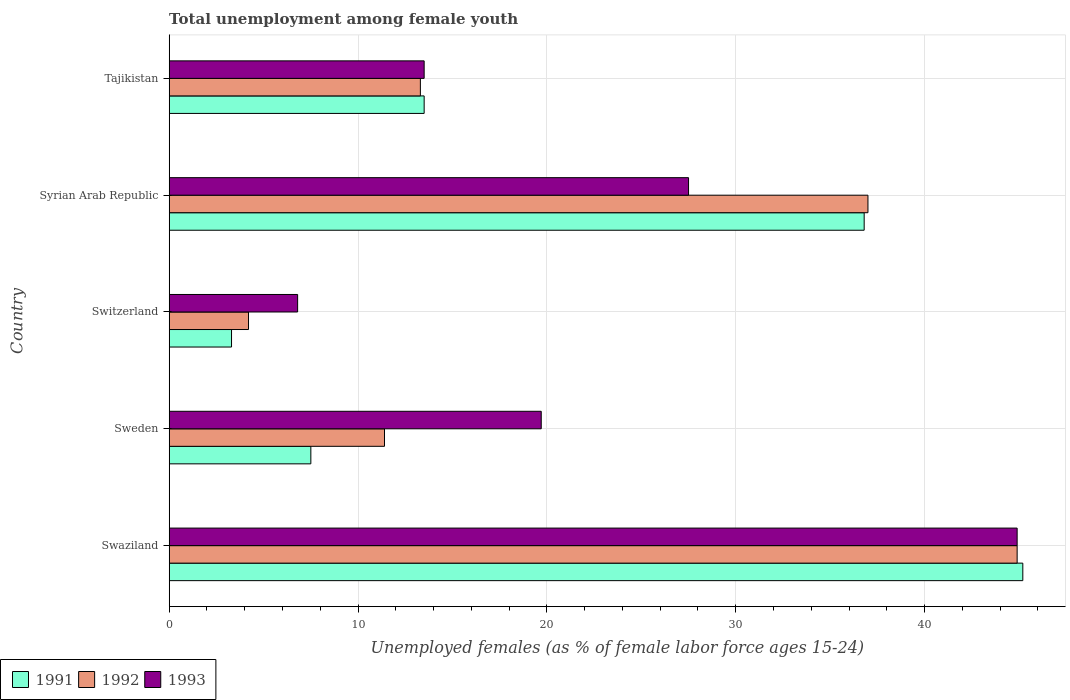Are the number of bars on each tick of the Y-axis equal?
Provide a short and direct response. Yes. How many bars are there on the 3rd tick from the bottom?
Provide a short and direct response. 3. What is the label of the 5th group of bars from the top?
Make the answer very short. Swaziland. Across all countries, what is the maximum percentage of unemployed females in in 1992?
Make the answer very short. 44.9. Across all countries, what is the minimum percentage of unemployed females in in 1991?
Offer a very short reply. 3.3. In which country was the percentage of unemployed females in in 1993 maximum?
Keep it short and to the point. Swaziland. In which country was the percentage of unemployed females in in 1991 minimum?
Offer a terse response. Switzerland. What is the total percentage of unemployed females in in 1992 in the graph?
Make the answer very short. 110.8. What is the difference between the percentage of unemployed females in in 1991 in Sweden and that in Syrian Arab Republic?
Ensure brevity in your answer.  -29.3. What is the difference between the percentage of unemployed females in in 1993 in Swaziland and the percentage of unemployed females in in 1991 in Sweden?
Provide a short and direct response. 37.4. What is the average percentage of unemployed females in in 1993 per country?
Ensure brevity in your answer.  22.48. What is the difference between the percentage of unemployed females in in 1992 and percentage of unemployed females in in 1991 in Switzerland?
Give a very brief answer. 0.9. In how many countries, is the percentage of unemployed females in in 1993 greater than 14 %?
Give a very brief answer. 3. What is the ratio of the percentage of unemployed females in in 1991 in Switzerland to that in Syrian Arab Republic?
Your answer should be compact. 0.09. Is the difference between the percentage of unemployed females in in 1992 in Swaziland and Switzerland greater than the difference between the percentage of unemployed females in in 1991 in Swaziland and Switzerland?
Provide a succinct answer. No. What is the difference between the highest and the second highest percentage of unemployed females in in 1992?
Your answer should be compact. 7.9. What is the difference between the highest and the lowest percentage of unemployed females in in 1991?
Your answer should be very brief. 41.9. In how many countries, is the percentage of unemployed females in in 1992 greater than the average percentage of unemployed females in in 1992 taken over all countries?
Keep it short and to the point. 2. What does the 3rd bar from the bottom in Swaziland represents?
Keep it short and to the point. 1993. Is it the case that in every country, the sum of the percentage of unemployed females in in 1993 and percentage of unemployed females in in 1992 is greater than the percentage of unemployed females in in 1991?
Keep it short and to the point. Yes. How many bars are there?
Provide a short and direct response. 15. What is the difference between two consecutive major ticks on the X-axis?
Your answer should be very brief. 10. Are the values on the major ticks of X-axis written in scientific E-notation?
Offer a very short reply. No. Does the graph contain grids?
Offer a terse response. Yes. Where does the legend appear in the graph?
Offer a terse response. Bottom left. How many legend labels are there?
Provide a short and direct response. 3. How are the legend labels stacked?
Offer a terse response. Horizontal. What is the title of the graph?
Keep it short and to the point. Total unemployment among female youth. Does "1971" appear as one of the legend labels in the graph?
Your answer should be compact. No. What is the label or title of the X-axis?
Provide a succinct answer. Unemployed females (as % of female labor force ages 15-24). What is the label or title of the Y-axis?
Offer a very short reply. Country. What is the Unemployed females (as % of female labor force ages 15-24) in 1991 in Swaziland?
Offer a terse response. 45.2. What is the Unemployed females (as % of female labor force ages 15-24) of 1992 in Swaziland?
Make the answer very short. 44.9. What is the Unemployed females (as % of female labor force ages 15-24) in 1993 in Swaziland?
Ensure brevity in your answer.  44.9. What is the Unemployed females (as % of female labor force ages 15-24) in 1992 in Sweden?
Make the answer very short. 11.4. What is the Unemployed females (as % of female labor force ages 15-24) of 1993 in Sweden?
Give a very brief answer. 19.7. What is the Unemployed females (as % of female labor force ages 15-24) of 1991 in Switzerland?
Your answer should be very brief. 3.3. What is the Unemployed females (as % of female labor force ages 15-24) in 1992 in Switzerland?
Give a very brief answer. 4.2. What is the Unemployed females (as % of female labor force ages 15-24) of 1993 in Switzerland?
Keep it short and to the point. 6.8. What is the Unemployed females (as % of female labor force ages 15-24) of 1991 in Syrian Arab Republic?
Give a very brief answer. 36.8. What is the Unemployed females (as % of female labor force ages 15-24) of 1992 in Syrian Arab Republic?
Your answer should be compact. 37. What is the Unemployed females (as % of female labor force ages 15-24) in 1991 in Tajikistan?
Make the answer very short. 13.5. What is the Unemployed females (as % of female labor force ages 15-24) of 1992 in Tajikistan?
Keep it short and to the point. 13.3. Across all countries, what is the maximum Unemployed females (as % of female labor force ages 15-24) in 1991?
Provide a short and direct response. 45.2. Across all countries, what is the maximum Unemployed females (as % of female labor force ages 15-24) of 1992?
Keep it short and to the point. 44.9. Across all countries, what is the maximum Unemployed females (as % of female labor force ages 15-24) in 1993?
Keep it short and to the point. 44.9. Across all countries, what is the minimum Unemployed females (as % of female labor force ages 15-24) in 1991?
Your answer should be compact. 3.3. Across all countries, what is the minimum Unemployed females (as % of female labor force ages 15-24) of 1992?
Make the answer very short. 4.2. Across all countries, what is the minimum Unemployed females (as % of female labor force ages 15-24) in 1993?
Provide a short and direct response. 6.8. What is the total Unemployed females (as % of female labor force ages 15-24) in 1991 in the graph?
Offer a very short reply. 106.3. What is the total Unemployed females (as % of female labor force ages 15-24) in 1992 in the graph?
Provide a short and direct response. 110.8. What is the total Unemployed females (as % of female labor force ages 15-24) in 1993 in the graph?
Provide a succinct answer. 112.4. What is the difference between the Unemployed females (as % of female labor force ages 15-24) of 1991 in Swaziland and that in Sweden?
Offer a terse response. 37.7. What is the difference between the Unemployed females (as % of female labor force ages 15-24) of 1992 in Swaziland and that in Sweden?
Your answer should be very brief. 33.5. What is the difference between the Unemployed females (as % of female labor force ages 15-24) of 1993 in Swaziland and that in Sweden?
Your response must be concise. 25.2. What is the difference between the Unemployed females (as % of female labor force ages 15-24) of 1991 in Swaziland and that in Switzerland?
Offer a very short reply. 41.9. What is the difference between the Unemployed females (as % of female labor force ages 15-24) of 1992 in Swaziland and that in Switzerland?
Give a very brief answer. 40.7. What is the difference between the Unemployed females (as % of female labor force ages 15-24) of 1993 in Swaziland and that in Switzerland?
Give a very brief answer. 38.1. What is the difference between the Unemployed females (as % of female labor force ages 15-24) of 1992 in Swaziland and that in Syrian Arab Republic?
Make the answer very short. 7.9. What is the difference between the Unemployed females (as % of female labor force ages 15-24) of 1991 in Swaziland and that in Tajikistan?
Keep it short and to the point. 31.7. What is the difference between the Unemployed females (as % of female labor force ages 15-24) in 1992 in Swaziland and that in Tajikistan?
Give a very brief answer. 31.6. What is the difference between the Unemployed females (as % of female labor force ages 15-24) in 1993 in Swaziland and that in Tajikistan?
Offer a terse response. 31.4. What is the difference between the Unemployed females (as % of female labor force ages 15-24) of 1991 in Sweden and that in Switzerland?
Your answer should be compact. 4.2. What is the difference between the Unemployed females (as % of female labor force ages 15-24) of 1992 in Sweden and that in Switzerland?
Your answer should be very brief. 7.2. What is the difference between the Unemployed females (as % of female labor force ages 15-24) of 1991 in Sweden and that in Syrian Arab Republic?
Your response must be concise. -29.3. What is the difference between the Unemployed females (as % of female labor force ages 15-24) of 1992 in Sweden and that in Syrian Arab Republic?
Your answer should be very brief. -25.6. What is the difference between the Unemployed females (as % of female labor force ages 15-24) of 1993 in Sweden and that in Syrian Arab Republic?
Ensure brevity in your answer.  -7.8. What is the difference between the Unemployed females (as % of female labor force ages 15-24) of 1991 in Sweden and that in Tajikistan?
Your answer should be very brief. -6. What is the difference between the Unemployed females (as % of female labor force ages 15-24) in 1992 in Sweden and that in Tajikistan?
Your answer should be compact. -1.9. What is the difference between the Unemployed females (as % of female labor force ages 15-24) in 1991 in Switzerland and that in Syrian Arab Republic?
Offer a terse response. -33.5. What is the difference between the Unemployed females (as % of female labor force ages 15-24) in 1992 in Switzerland and that in Syrian Arab Republic?
Offer a terse response. -32.8. What is the difference between the Unemployed females (as % of female labor force ages 15-24) of 1993 in Switzerland and that in Syrian Arab Republic?
Make the answer very short. -20.7. What is the difference between the Unemployed females (as % of female labor force ages 15-24) of 1993 in Switzerland and that in Tajikistan?
Keep it short and to the point. -6.7. What is the difference between the Unemployed females (as % of female labor force ages 15-24) of 1991 in Syrian Arab Republic and that in Tajikistan?
Provide a succinct answer. 23.3. What is the difference between the Unemployed females (as % of female labor force ages 15-24) of 1992 in Syrian Arab Republic and that in Tajikistan?
Provide a short and direct response. 23.7. What is the difference between the Unemployed females (as % of female labor force ages 15-24) in 1993 in Syrian Arab Republic and that in Tajikistan?
Keep it short and to the point. 14. What is the difference between the Unemployed females (as % of female labor force ages 15-24) of 1991 in Swaziland and the Unemployed females (as % of female labor force ages 15-24) of 1992 in Sweden?
Your answer should be compact. 33.8. What is the difference between the Unemployed females (as % of female labor force ages 15-24) in 1991 in Swaziland and the Unemployed females (as % of female labor force ages 15-24) in 1993 in Sweden?
Keep it short and to the point. 25.5. What is the difference between the Unemployed females (as % of female labor force ages 15-24) of 1992 in Swaziland and the Unemployed females (as % of female labor force ages 15-24) of 1993 in Sweden?
Offer a terse response. 25.2. What is the difference between the Unemployed females (as % of female labor force ages 15-24) in 1991 in Swaziland and the Unemployed females (as % of female labor force ages 15-24) in 1992 in Switzerland?
Ensure brevity in your answer.  41. What is the difference between the Unemployed females (as % of female labor force ages 15-24) in 1991 in Swaziland and the Unemployed females (as % of female labor force ages 15-24) in 1993 in Switzerland?
Your answer should be compact. 38.4. What is the difference between the Unemployed females (as % of female labor force ages 15-24) in 1992 in Swaziland and the Unemployed females (as % of female labor force ages 15-24) in 1993 in Switzerland?
Make the answer very short. 38.1. What is the difference between the Unemployed females (as % of female labor force ages 15-24) in 1992 in Swaziland and the Unemployed females (as % of female labor force ages 15-24) in 1993 in Syrian Arab Republic?
Make the answer very short. 17.4. What is the difference between the Unemployed females (as % of female labor force ages 15-24) of 1991 in Swaziland and the Unemployed females (as % of female labor force ages 15-24) of 1992 in Tajikistan?
Give a very brief answer. 31.9. What is the difference between the Unemployed females (as % of female labor force ages 15-24) in 1991 in Swaziland and the Unemployed females (as % of female labor force ages 15-24) in 1993 in Tajikistan?
Ensure brevity in your answer.  31.7. What is the difference between the Unemployed females (as % of female labor force ages 15-24) of 1992 in Swaziland and the Unemployed females (as % of female labor force ages 15-24) of 1993 in Tajikistan?
Provide a succinct answer. 31.4. What is the difference between the Unemployed females (as % of female labor force ages 15-24) of 1991 in Sweden and the Unemployed females (as % of female labor force ages 15-24) of 1993 in Switzerland?
Provide a short and direct response. 0.7. What is the difference between the Unemployed females (as % of female labor force ages 15-24) of 1992 in Sweden and the Unemployed females (as % of female labor force ages 15-24) of 1993 in Switzerland?
Your answer should be very brief. 4.6. What is the difference between the Unemployed females (as % of female labor force ages 15-24) of 1991 in Sweden and the Unemployed females (as % of female labor force ages 15-24) of 1992 in Syrian Arab Republic?
Your answer should be very brief. -29.5. What is the difference between the Unemployed females (as % of female labor force ages 15-24) in 1991 in Sweden and the Unemployed females (as % of female labor force ages 15-24) in 1993 in Syrian Arab Republic?
Offer a very short reply. -20. What is the difference between the Unemployed females (as % of female labor force ages 15-24) of 1992 in Sweden and the Unemployed females (as % of female labor force ages 15-24) of 1993 in Syrian Arab Republic?
Your answer should be compact. -16.1. What is the difference between the Unemployed females (as % of female labor force ages 15-24) of 1991 in Switzerland and the Unemployed females (as % of female labor force ages 15-24) of 1992 in Syrian Arab Republic?
Offer a terse response. -33.7. What is the difference between the Unemployed females (as % of female labor force ages 15-24) in 1991 in Switzerland and the Unemployed females (as % of female labor force ages 15-24) in 1993 in Syrian Arab Republic?
Ensure brevity in your answer.  -24.2. What is the difference between the Unemployed females (as % of female labor force ages 15-24) of 1992 in Switzerland and the Unemployed females (as % of female labor force ages 15-24) of 1993 in Syrian Arab Republic?
Keep it short and to the point. -23.3. What is the difference between the Unemployed females (as % of female labor force ages 15-24) in 1991 in Switzerland and the Unemployed females (as % of female labor force ages 15-24) in 1992 in Tajikistan?
Your answer should be very brief. -10. What is the difference between the Unemployed females (as % of female labor force ages 15-24) of 1991 in Syrian Arab Republic and the Unemployed females (as % of female labor force ages 15-24) of 1993 in Tajikistan?
Keep it short and to the point. 23.3. What is the average Unemployed females (as % of female labor force ages 15-24) of 1991 per country?
Offer a terse response. 21.26. What is the average Unemployed females (as % of female labor force ages 15-24) in 1992 per country?
Give a very brief answer. 22.16. What is the average Unemployed females (as % of female labor force ages 15-24) in 1993 per country?
Ensure brevity in your answer.  22.48. What is the difference between the Unemployed females (as % of female labor force ages 15-24) of 1992 and Unemployed females (as % of female labor force ages 15-24) of 1993 in Sweden?
Offer a very short reply. -8.3. What is the difference between the Unemployed females (as % of female labor force ages 15-24) of 1991 and Unemployed females (as % of female labor force ages 15-24) of 1993 in Switzerland?
Offer a terse response. -3.5. What is the difference between the Unemployed females (as % of female labor force ages 15-24) of 1992 and Unemployed females (as % of female labor force ages 15-24) of 1993 in Switzerland?
Keep it short and to the point. -2.6. What is the difference between the Unemployed females (as % of female labor force ages 15-24) in 1992 and Unemployed females (as % of female labor force ages 15-24) in 1993 in Syrian Arab Republic?
Ensure brevity in your answer.  9.5. What is the difference between the Unemployed females (as % of female labor force ages 15-24) in 1991 and Unemployed females (as % of female labor force ages 15-24) in 1992 in Tajikistan?
Ensure brevity in your answer.  0.2. What is the difference between the Unemployed females (as % of female labor force ages 15-24) of 1992 and Unemployed females (as % of female labor force ages 15-24) of 1993 in Tajikistan?
Provide a short and direct response. -0.2. What is the ratio of the Unemployed females (as % of female labor force ages 15-24) in 1991 in Swaziland to that in Sweden?
Keep it short and to the point. 6.03. What is the ratio of the Unemployed females (as % of female labor force ages 15-24) in 1992 in Swaziland to that in Sweden?
Offer a terse response. 3.94. What is the ratio of the Unemployed females (as % of female labor force ages 15-24) in 1993 in Swaziland to that in Sweden?
Give a very brief answer. 2.28. What is the ratio of the Unemployed females (as % of female labor force ages 15-24) of 1991 in Swaziland to that in Switzerland?
Offer a terse response. 13.7. What is the ratio of the Unemployed females (as % of female labor force ages 15-24) of 1992 in Swaziland to that in Switzerland?
Offer a terse response. 10.69. What is the ratio of the Unemployed females (as % of female labor force ages 15-24) of 1993 in Swaziland to that in Switzerland?
Your answer should be compact. 6.6. What is the ratio of the Unemployed females (as % of female labor force ages 15-24) in 1991 in Swaziland to that in Syrian Arab Republic?
Provide a succinct answer. 1.23. What is the ratio of the Unemployed females (as % of female labor force ages 15-24) in 1992 in Swaziland to that in Syrian Arab Republic?
Keep it short and to the point. 1.21. What is the ratio of the Unemployed females (as % of female labor force ages 15-24) of 1993 in Swaziland to that in Syrian Arab Republic?
Your answer should be very brief. 1.63. What is the ratio of the Unemployed females (as % of female labor force ages 15-24) in 1991 in Swaziland to that in Tajikistan?
Make the answer very short. 3.35. What is the ratio of the Unemployed females (as % of female labor force ages 15-24) in 1992 in Swaziland to that in Tajikistan?
Offer a terse response. 3.38. What is the ratio of the Unemployed females (as % of female labor force ages 15-24) in 1993 in Swaziland to that in Tajikistan?
Your answer should be compact. 3.33. What is the ratio of the Unemployed females (as % of female labor force ages 15-24) in 1991 in Sweden to that in Switzerland?
Keep it short and to the point. 2.27. What is the ratio of the Unemployed females (as % of female labor force ages 15-24) of 1992 in Sweden to that in Switzerland?
Give a very brief answer. 2.71. What is the ratio of the Unemployed females (as % of female labor force ages 15-24) in 1993 in Sweden to that in Switzerland?
Ensure brevity in your answer.  2.9. What is the ratio of the Unemployed females (as % of female labor force ages 15-24) in 1991 in Sweden to that in Syrian Arab Republic?
Provide a succinct answer. 0.2. What is the ratio of the Unemployed females (as % of female labor force ages 15-24) of 1992 in Sweden to that in Syrian Arab Republic?
Provide a succinct answer. 0.31. What is the ratio of the Unemployed females (as % of female labor force ages 15-24) of 1993 in Sweden to that in Syrian Arab Republic?
Provide a short and direct response. 0.72. What is the ratio of the Unemployed females (as % of female labor force ages 15-24) of 1991 in Sweden to that in Tajikistan?
Give a very brief answer. 0.56. What is the ratio of the Unemployed females (as % of female labor force ages 15-24) of 1993 in Sweden to that in Tajikistan?
Provide a succinct answer. 1.46. What is the ratio of the Unemployed females (as % of female labor force ages 15-24) of 1991 in Switzerland to that in Syrian Arab Republic?
Keep it short and to the point. 0.09. What is the ratio of the Unemployed females (as % of female labor force ages 15-24) of 1992 in Switzerland to that in Syrian Arab Republic?
Make the answer very short. 0.11. What is the ratio of the Unemployed females (as % of female labor force ages 15-24) of 1993 in Switzerland to that in Syrian Arab Republic?
Keep it short and to the point. 0.25. What is the ratio of the Unemployed females (as % of female labor force ages 15-24) in 1991 in Switzerland to that in Tajikistan?
Make the answer very short. 0.24. What is the ratio of the Unemployed females (as % of female labor force ages 15-24) of 1992 in Switzerland to that in Tajikistan?
Offer a terse response. 0.32. What is the ratio of the Unemployed females (as % of female labor force ages 15-24) in 1993 in Switzerland to that in Tajikistan?
Keep it short and to the point. 0.5. What is the ratio of the Unemployed females (as % of female labor force ages 15-24) of 1991 in Syrian Arab Republic to that in Tajikistan?
Keep it short and to the point. 2.73. What is the ratio of the Unemployed females (as % of female labor force ages 15-24) in 1992 in Syrian Arab Republic to that in Tajikistan?
Offer a very short reply. 2.78. What is the ratio of the Unemployed females (as % of female labor force ages 15-24) of 1993 in Syrian Arab Republic to that in Tajikistan?
Keep it short and to the point. 2.04. What is the difference between the highest and the second highest Unemployed females (as % of female labor force ages 15-24) of 1992?
Make the answer very short. 7.9. What is the difference between the highest and the lowest Unemployed females (as % of female labor force ages 15-24) of 1991?
Give a very brief answer. 41.9. What is the difference between the highest and the lowest Unemployed females (as % of female labor force ages 15-24) in 1992?
Provide a short and direct response. 40.7. What is the difference between the highest and the lowest Unemployed females (as % of female labor force ages 15-24) of 1993?
Your response must be concise. 38.1. 